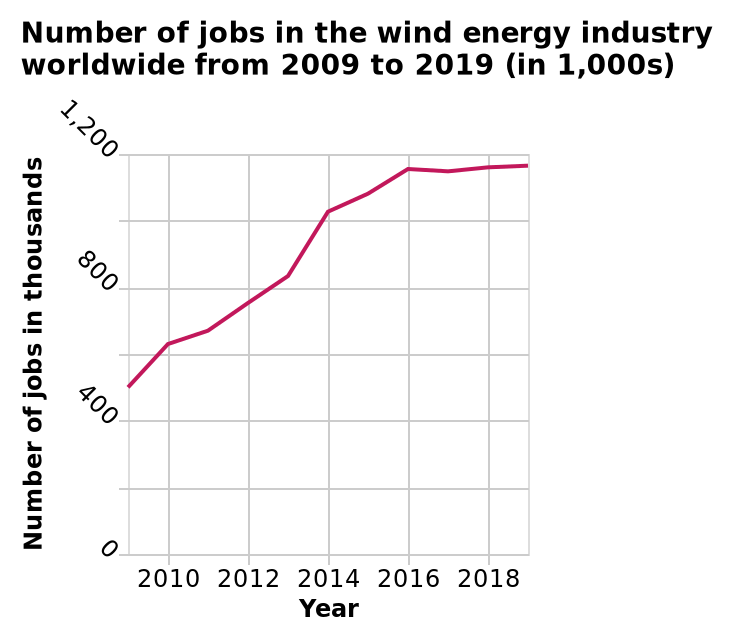<image>
What is the title of the line chart? The title of the line chart is "Number of jobs in the wind energy industry worldwide from 2009 to 2019 (in 1,000s)." Has the number of jobs in the wind energy industry decreased at any point during the mentioned period? No, the description does not mention any decrease in the number of jobs. Does the figure mention a decrease in the number of jobs? No.No, the figure does not mention any decrease in the number of jobs. 